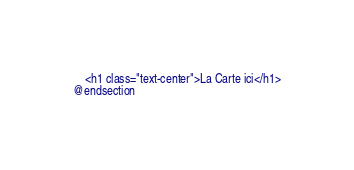Convert code to text. <code><loc_0><loc_0><loc_500><loc_500><_PHP_>    <h1 class="text-center">La Carte ici</h1>
@endsection</code> 